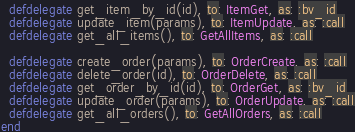<code> <loc_0><loc_0><loc_500><loc_500><_Elixir_>  defdelegate get_item_by_id(id), to: ItemGet, as: :by_id
  defdelegate update_item(params), to: ItemUpdate, as: :call
  defdelegate get_all_items(), to: GetAllItems, as: :call

  defdelegate create_order(params), to: OrderCreate, as: :call
  defdelegate delete_order(id), to: OrderDelete, as: :call
  defdelegate get_order_by_id(id), to: OrderGet, as: :by_id
  defdelegate update_order(params), to: OrderUpdate, as: :call
  defdelegate get_all_orders(), to: GetAllOrders, as: :call
end
</code> 